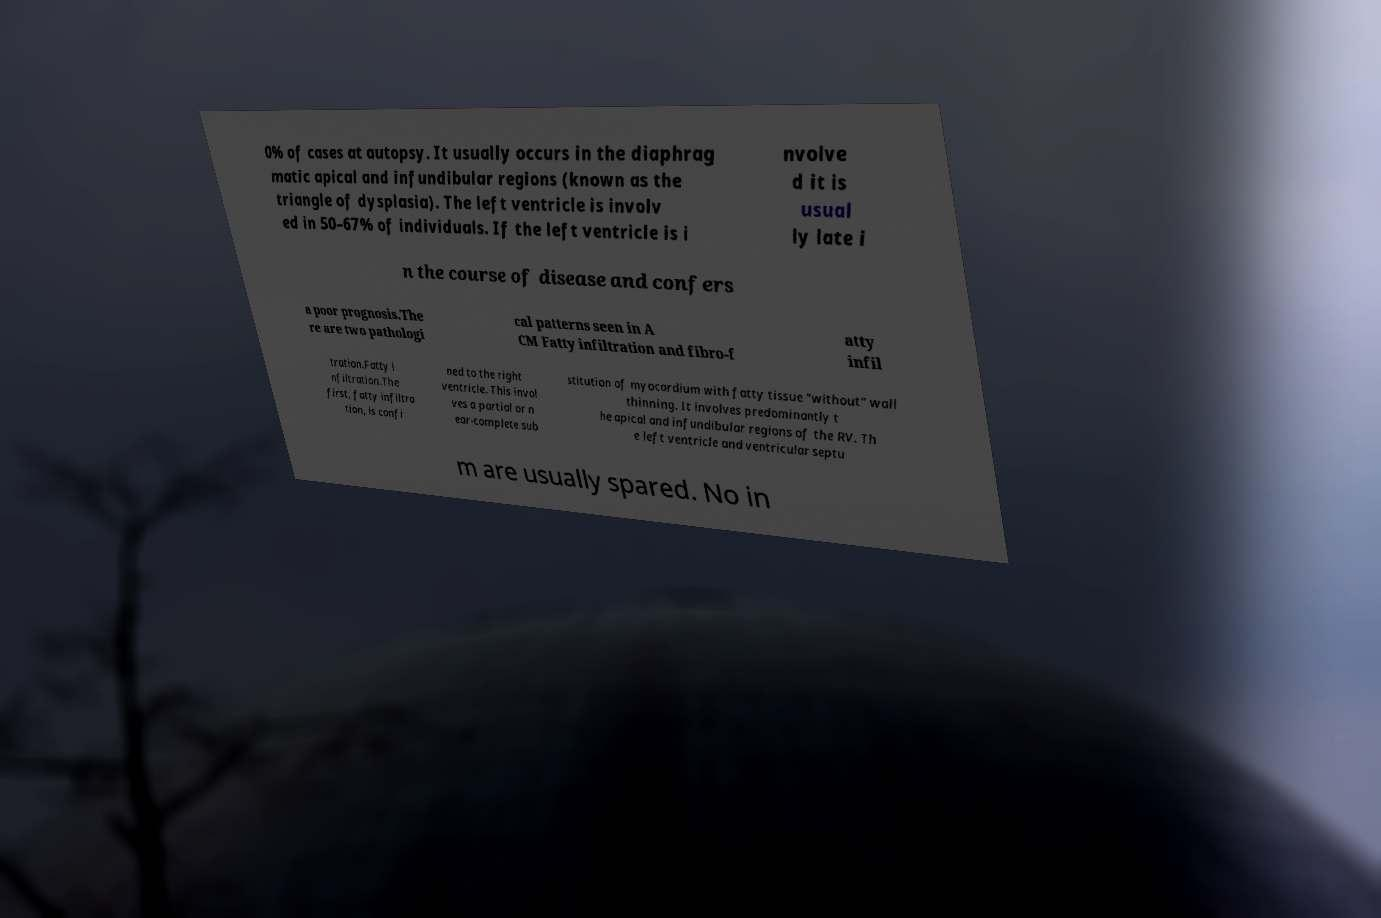Please read and relay the text visible in this image. What does it say? 0% of cases at autopsy. It usually occurs in the diaphrag matic apical and infundibular regions (known as the triangle of dysplasia). The left ventricle is involv ed in 50–67% of individuals. If the left ventricle is i nvolve d it is usual ly late i n the course of disease and confers a poor prognosis.The re are two pathologi cal patterns seen in A CM Fatty infiltration and fibro-f atty infil tration.Fatty i nfiltration.The first, fatty infiltra tion, is confi ned to the right ventricle. This invol ves a partial or n ear-complete sub stitution of myocardium with fatty tissue "without" wall thinning. It involves predominantly t he apical and infundibular regions of the RV. Th e left ventricle and ventricular septu m are usually spared. No in 